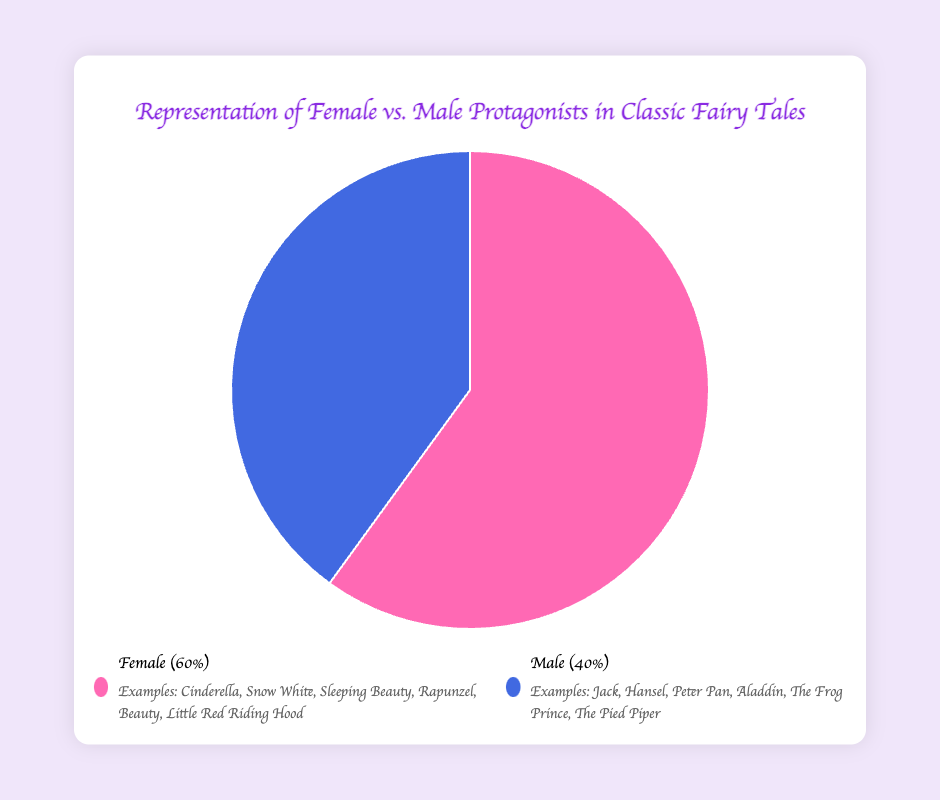What percentage of the protagonists are female? The pie chart has one section for Females, which is labeled as 60%.
Answer: 60% What percentage of the protagonists are male? The pie chart has one section for males, which is labeled as 40%.
Answer: 40% Which gender has a higher representation in the classic fairy tales? Comparing the two sections of the pie chart, Female has 60% while Male has 40%, so Females have a higher representation.
Answer: Females What is the ratio of female to male protagonists in the classic fairy tales? From the pie chart, we know Females are 60%, and Males are 40%. The ratio is 60:40 or simplified, 3:2.
Answer: 3:2 What is the difference in the number of fairy tales featuring female and male protagonists? Calculate the difference using the percentages provided: 60% - 40% = 20%.
Answer: 20% What portion of the pie chart is more prominent in terms of visual area? The larger section of the pie chart, representing Females, occupies a greater visual area at 60%.
Answer: Females List three fairy tales with male protagonists as shown in the legend. The legend under the pie chart lists: Jack (Jack and the Beanstalk), Hansel (Hansel and Gretel), Peter Pan.
Answer: Jack, Hansel, Peter Pan List three fairy tales with female protagonists as shown in the legend. The legend under the pie chart lists: Cinderella, Snow White, Sleeping Beauty.
Answer: Cinderella, Snow White, Sleeping Beauty By what factor is the number of fairy tales with female protagonists greater than those with male protagonists? Calculate the factor by dividing the percentage of females by the percentage of males: 60% / 40% = 1.5.
Answer: 1.5 If 20 more tales were analyzed and all had male protagonists, how would the percentage change for males? Currently, there are 100 tales (60 females, 40 males). Adding 20 males makes 60 males out of 120 tales. The new percentage for males is (60/120)*100 = 50%.
Answer: 50% 